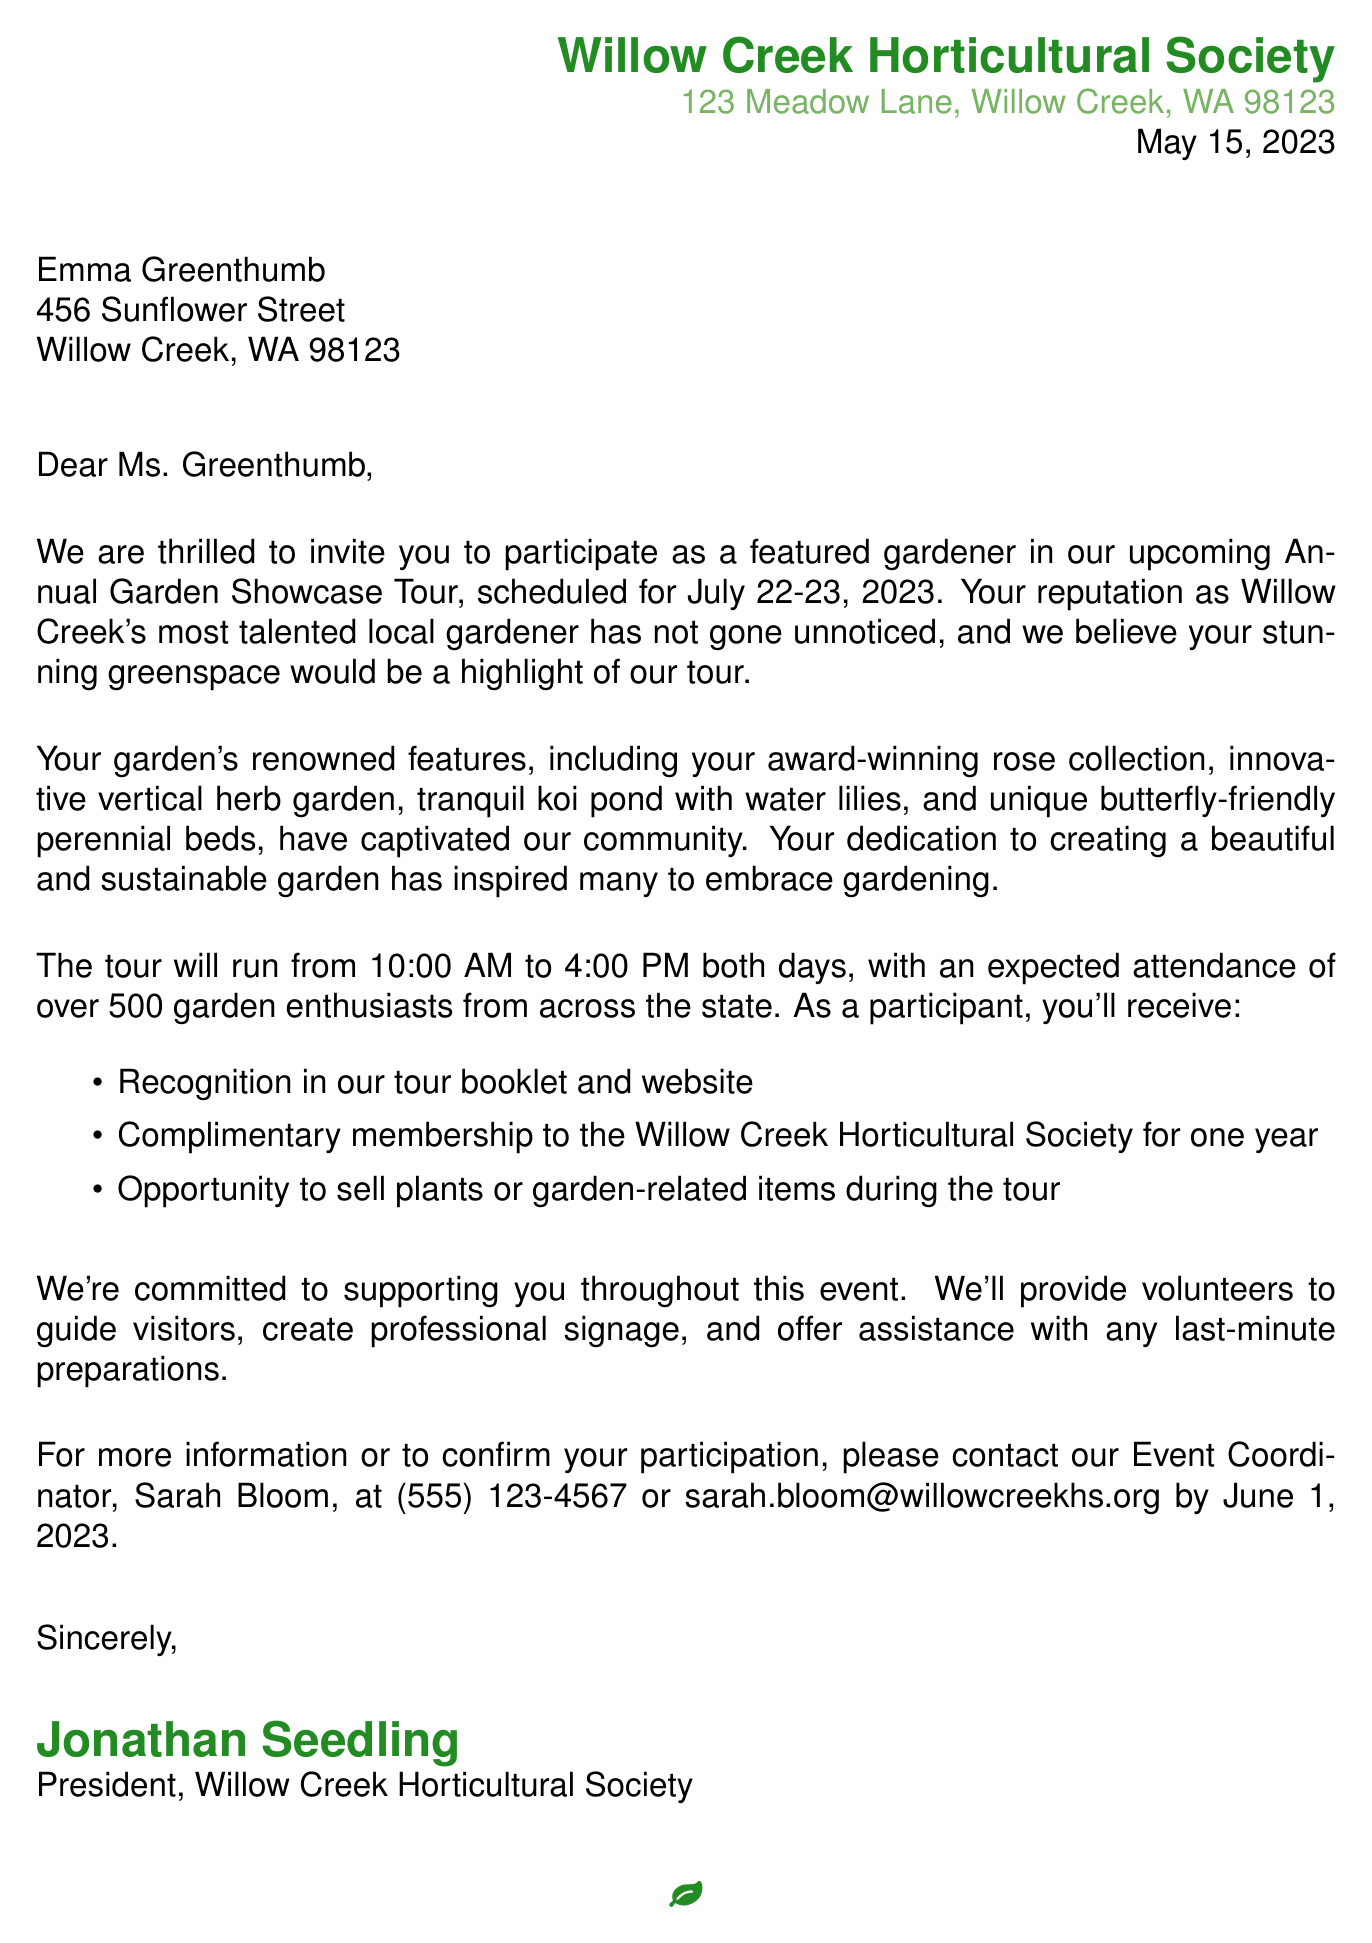What is the name of the organization? The name of the organization is indicated at the top of the letter, which is the Willow Creek Horticultural Society.
Answer: Willow Creek Horticultural Society What is the date of the letter? The date of the letter is also explicitly provided in the header section of the document.
Answer: May 15, 2023 What are the event dates for the Annual Garden Showcase Tour? The event dates for the tour are mentioned in the introduction paragraph of the letter.
Answer: July 22-23, 2023 Who is the recipient of the letter? The recipient's name is specified at the beginning of the letter, addressing them directly.
Answer: Emma Greenthumb What are two features of the garden that are highlighted? Two notable features are listed in the garden description section of the letter, detailing what will attract visitors.
Answer: Award-winning rose collection, innovative vertical herb garden How many garden enthusiasts are expected to attend the tour? The expected attendance is given in the event details section, reflecting the anticipated number of visitors.
Answer: Over 500 What support will be provided to the featured gardeners? Support details are outlined in the letter, specifying how the society will assist the participants during the event.
Answer: Volunteers to guide visitors When is the response deadline for participation? The deadline for responding to the invitation is clearly stated in the closing paragraph of the letter.
Answer: June 1, 2023 Who should be contacted for more information? The contact person's information, including name and title, is provided for further inquiries related to the event.
Answer: Sarah Bloom, Event Coordinator 